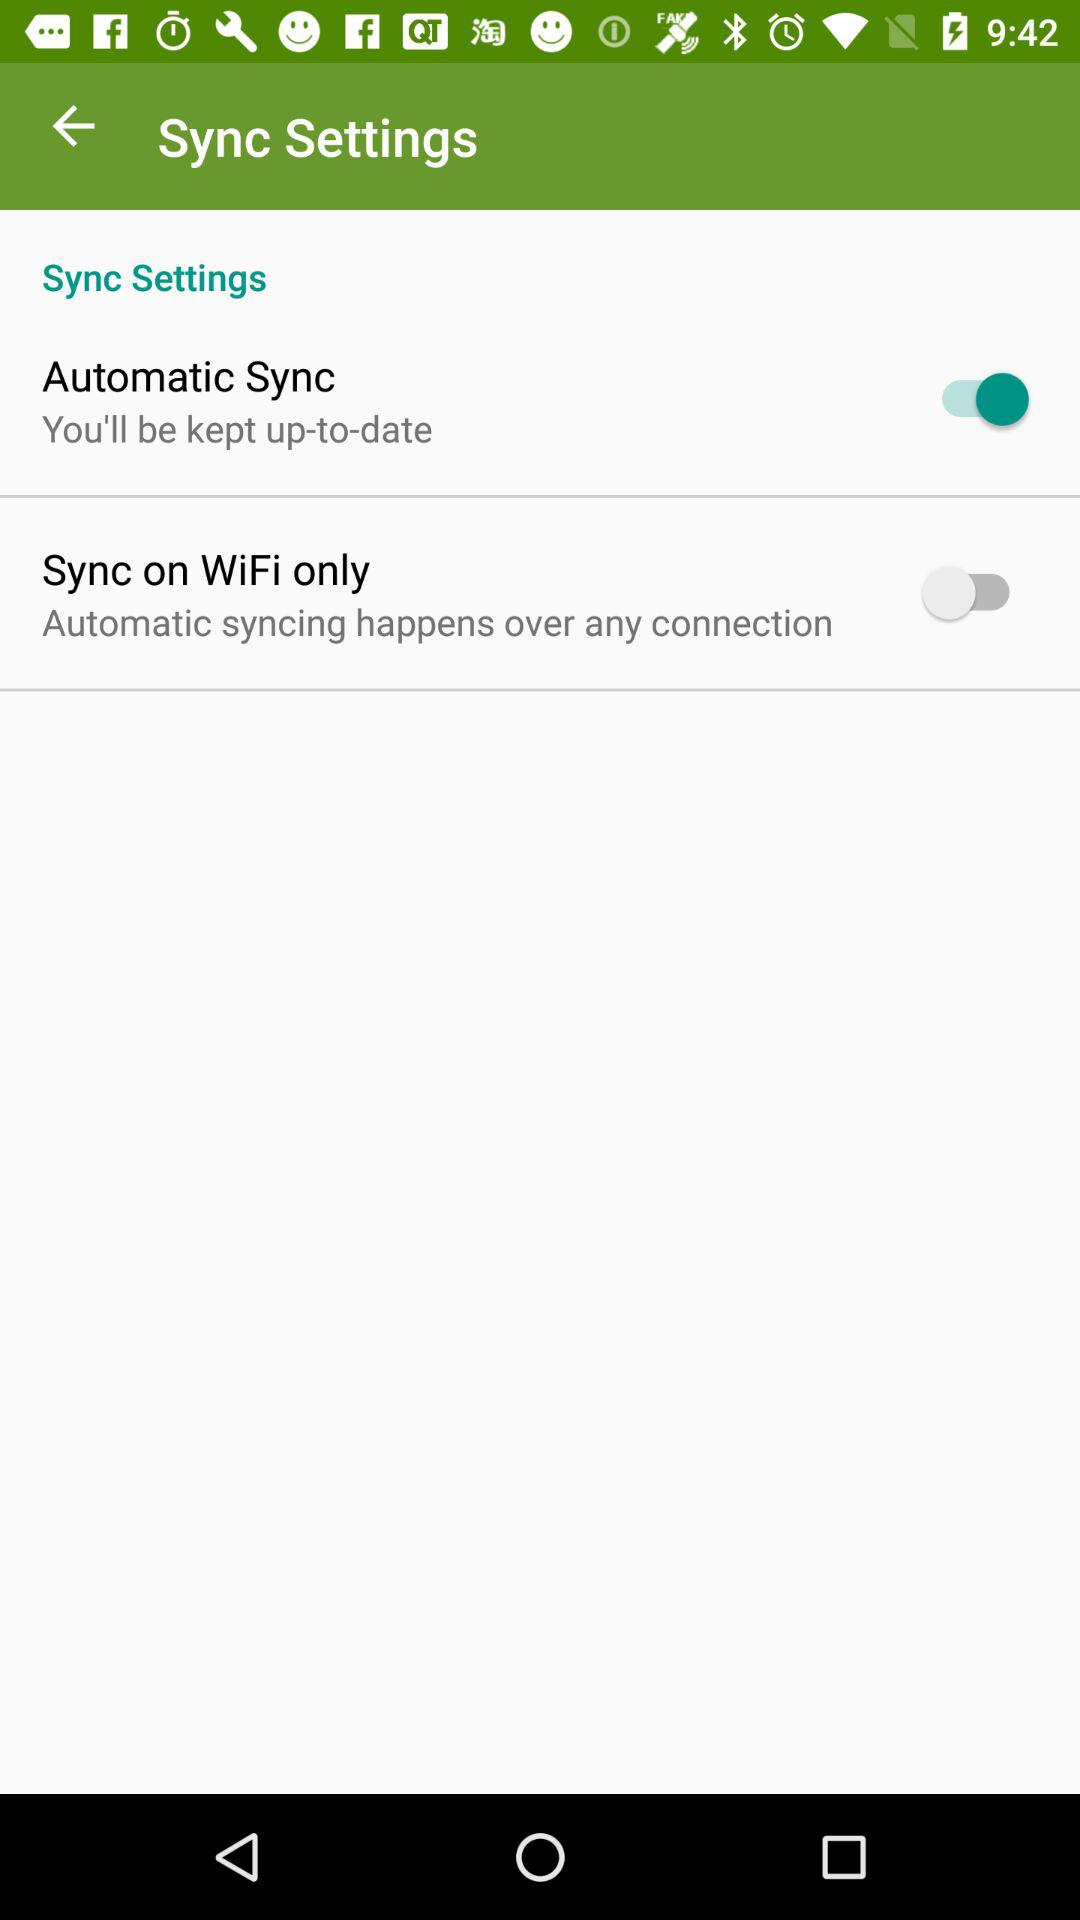What's the status of "Sync on WiFi only"? The status is "off". 